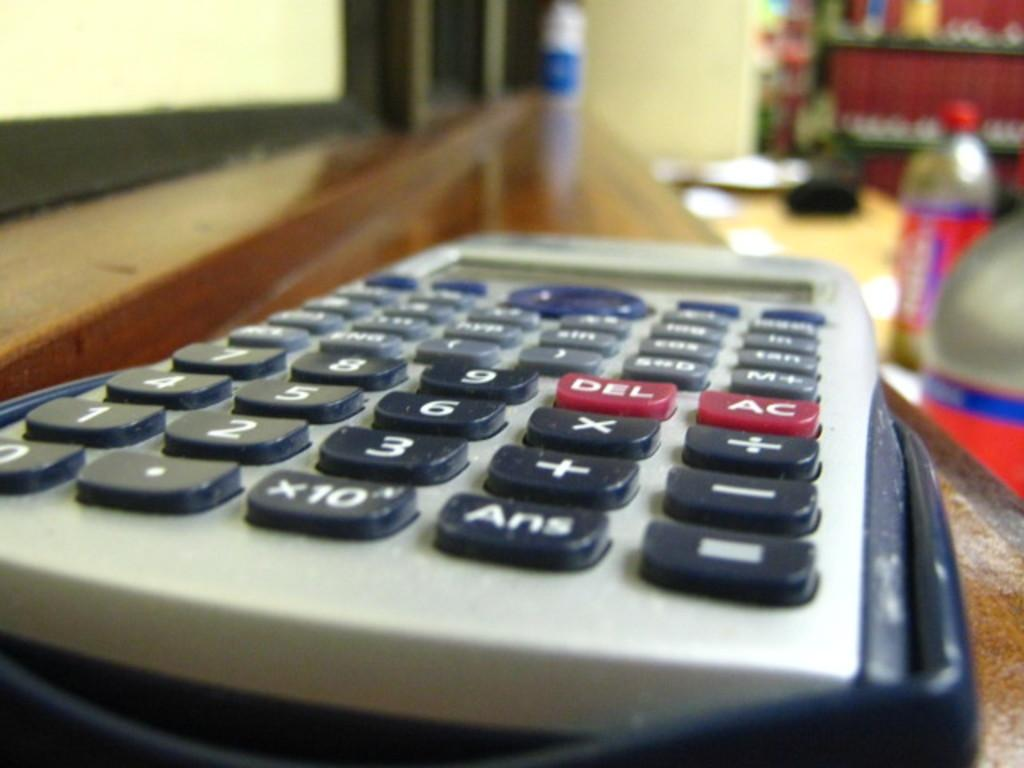Provide a one-sentence caption for the provided image. A close up of a calculator where the del and AC key can be seen. 